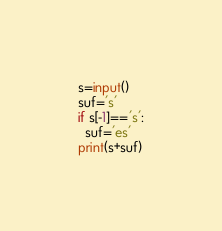Convert code to text. <code><loc_0><loc_0><loc_500><loc_500><_Python_>s=input()
suf='s'
if s[-1]=='s':
  suf='es'
print(s+suf)</code> 